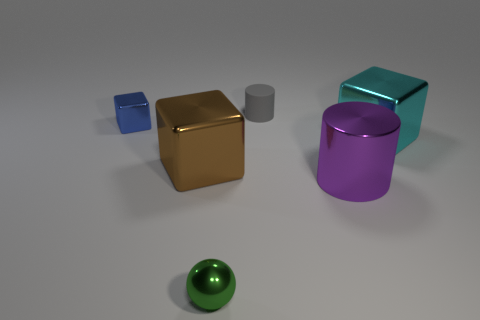There is a cylinder that is behind the large purple cylinder; what is its color?
Ensure brevity in your answer.  Gray. Are there fewer blue objects that are on the right side of the cyan metallic object than spheres that are on the left side of the tiny gray thing?
Ensure brevity in your answer.  Yes. How many gray matte things are behind the blue object?
Provide a succinct answer. 1. Are there any big gray balls that have the same material as the small gray object?
Provide a succinct answer. No. Are there more tiny balls to the left of the tiny gray thing than blue metal objects in front of the brown metallic thing?
Ensure brevity in your answer.  Yes. What is the size of the cyan metallic object?
Give a very brief answer. Large. There is a thing that is in front of the big metal cylinder; what shape is it?
Your answer should be compact. Sphere. Is the large cyan thing the same shape as the brown thing?
Keep it short and to the point. Yes. Is the number of small gray objects that are right of the purple shiny object the same as the number of blue rubber cylinders?
Make the answer very short. Yes. The brown metal object has what shape?
Your answer should be compact. Cube. 